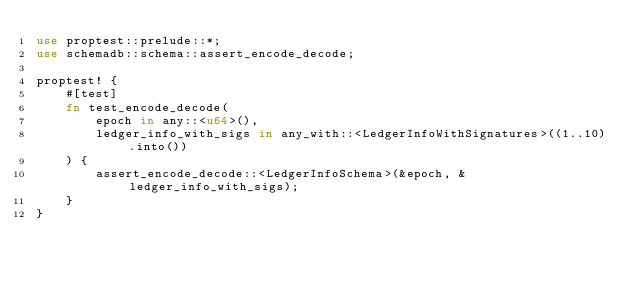Convert code to text. <code><loc_0><loc_0><loc_500><loc_500><_Rust_>use proptest::prelude::*;
use schemadb::schema::assert_encode_decode;

proptest! {
    #[test]
    fn test_encode_decode(
        epoch in any::<u64>(),
        ledger_info_with_sigs in any_with::<LedgerInfoWithSignatures>((1..10).into())
    ) {
        assert_encode_decode::<LedgerInfoSchema>(&epoch, &ledger_info_with_sigs);
    }
}
</code> 